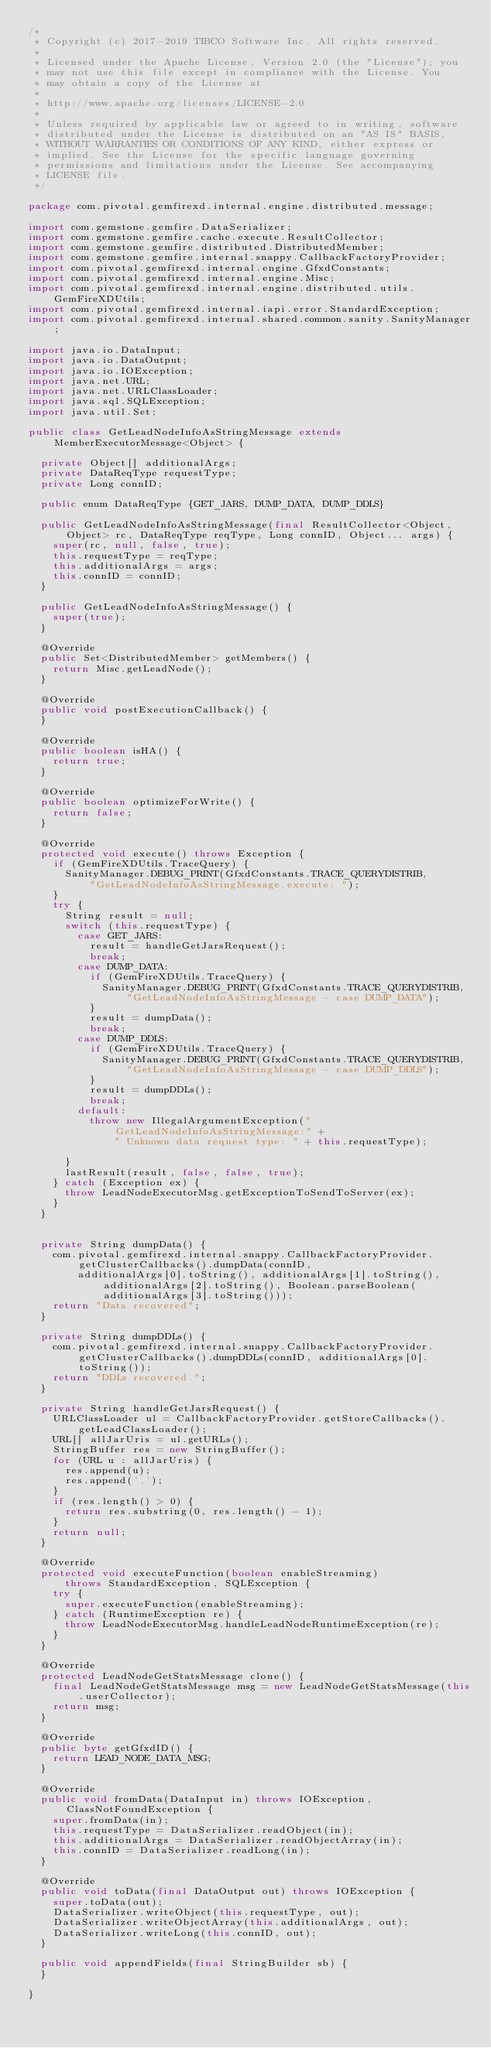Convert code to text. <code><loc_0><loc_0><loc_500><loc_500><_Java_>/*
 * Copyright (c) 2017-2019 TIBCO Software Inc. All rights reserved.
 *
 * Licensed under the Apache License, Version 2.0 (the "License"); you
 * may not use this file except in compliance with the License. You
 * may obtain a copy of the License at
 *
 * http://www.apache.org/licenses/LICENSE-2.0
 *
 * Unless required by applicable law or agreed to in writing, software
 * distributed under the License is distributed on an "AS IS" BASIS,
 * WITHOUT WARRANTIES OR CONDITIONS OF ANY KIND, either express or
 * implied. See the License for the specific language governing
 * permissions and limitations under the License. See accompanying
 * LICENSE file.
 */

package com.pivotal.gemfirexd.internal.engine.distributed.message;

import com.gemstone.gemfire.DataSerializer;
import com.gemstone.gemfire.cache.execute.ResultCollector;
import com.gemstone.gemfire.distributed.DistributedMember;
import com.gemstone.gemfire.internal.snappy.CallbackFactoryProvider;
import com.pivotal.gemfirexd.internal.engine.GfxdConstants;
import com.pivotal.gemfirexd.internal.engine.Misc;
import com.pivotal.gemfirexd.internal.engine.distributed.utils.GemFireXDUtils;
import com.pivotal.gemfirexd.internal.iapi.error.StandardException;
import com.pivotal.gemfirexd.internal.shared.common.sanity.SanityManager;

import java.io.DataInput;
import java.io.DataOutput;
import java.io.IOException;
import java.net.URL;
import java.net.URLClassLoader;
import java.sql.SQLException;
import java.util.Set;

public class GetLeadNodeInfoAsStringMessage extends MemberExecutorMessage<Object> {

  private Object[] additionalArgs;
  private DataReqType requestType;
  private Long connID;

  public enum DataReqType {GET_JARS, DUMP_DATA, DUMP_DDLS}

  public GetLeadNodeInfoAsStringMessage(final ResultCollector<Object, Object> rc, DataReqType reqType, Long connID, Object... args) {
    super(rc, null, false, true);
    this.requestType = reqType;
    this.additionalArgs = args;
    this.connID = connID;
  }

  public GetLeadNodeInfoAsStringMessage() {
    super(true);
  }

  @Override
  public Set<DistributedMember> getMembers() {
    return Misc.getLeadNode();
  }

  @Override
  public void postExecutionCallback() {
  }

  @Override
  public boolean isHA() {
    return true;
  }

  @Override
  public boolean optimizeForWrite() {
    return false;
  }

  @Override
  protected void execute() throws Exception {
    if (GemFireXDUtils.TraceQuery) {
      SanityManager.DEBUG_PRINT(GfxdConstants.TRACE_QUERYDISTRIB,
          "GetLeadNodeInfoAsStringMessage.execute: ");
    }
    try {
      String result = null;
      switch (this.requestType) {
        case GET_JARS:
          result = handleGetJarsRequest();
          break;
        case DUMP_DATA:
          if (GemFireXDUtils.TraceQuery) {
            SanityManager.DEBUG_PRINT(GfxdConstants.TRACE_QUERYDISTRIB,
                "GetLeadNodeInfoAsStringMessage - case DUMP_DATA");
          }
          result = dumpData();
          break;
        case DUMP_DDLS:
          if (GemFireXDUtils.TraceQuery) {
            SanityManager.DEBUG_PRINT(GfxdConstants.TRACE_QUERYDISTRIB,
                "GetLeadNodeInfoAsStringMessage - case DUMP_DDLS");
          }
          result = dumpDDLs();
          break;
        default:
          throw new IllegalArgumentException("GetLeadNodeInfoAsStringMessage:" +
              " Unknown data request type: " + this.requestType);

      }
      lastResult(result, false, false, true);
    } catch (Exception ex) {
      throw LeadNodeExecutorMsg.getExceptionToSendToServer(ex);
    }
  }


  private String dumpData() {
    com.pivotal.gemfirexd.internal.snappy.CallbackFactoryProvider.getClusterCallbacks().dumpData(connID,
        additionalArgs[0].toString(), additionalArgs[1].toString(), additionalArgs[2].toString(), Boolean.parseBoolean(additionalArgs[3].toString()));
    return "Data recovered";
  }

  private String dumpDDLs() {
    com.pivotal.gemfirexd.internal.snappy.CallbackFactoryProvider.getClusterCallbacks().dumpDDLs(connID, additionalArgs[0].toString());
    return "DDLs recovered.";
  }

  private String handleGetJarsRequest() {
    URLClassLoader ul = CallbackFactoryProvider.getStoreCallbacks().getLeadClassLoader();
    URL[] allJarUris = ul.getURLs();
    StringBuffer res = new StringBuffer();
    for (URL u : allJarUris) {
      res.append(u);
      res.append(',');
    }
    if (res.length() > 0) {
      return res.substring(0, res.length() - 1);
    }
    return null;
  }

  @Override
  protected void executeFunction(boolean enableStreaming)
      throws StandardException, SQLException {
    try {
      super.executeFunction(enableStreaming);
    } catch (RuntimeException re) {
      throw LeadNodeExecutorMsg.handleLeadNodeRuntimeException(re);
    }
  }

  @Override
  protected LeadNodeGetStatsMessage clone() {
    final LeadNodeGetStatsMessage msg = new LeadNodeGetStatsMessage(this.userCollector);
    return msg;
  }

  @Override
  public byte getGfxdID() {
    return LEAD_NODE_DATA_MSG;
  }

  @Override
  public void fromData(DataInput in) throws IOException, ClassNotFoundException {
    super.fromData(in);
    this.requestType = DataSerializer.readObject(in);
    this.additionalArgs = DataSerializer.readObjectArray(in);
    this.connID = DataSerializer.readLong(in);
  }

  @Override
  public void toData(final DataOutput out) throws IOException {
    super.toData(out);
    DataSerializer.writeObject(this.requestType, out);
    DataSerializer.writeObjectArray(this.additionalArgs, out);
    DataSerializer.writeLong(this.connID, out);
  }

  public void appendFields(final StringBuilder sb) {
  }

}

</code> 